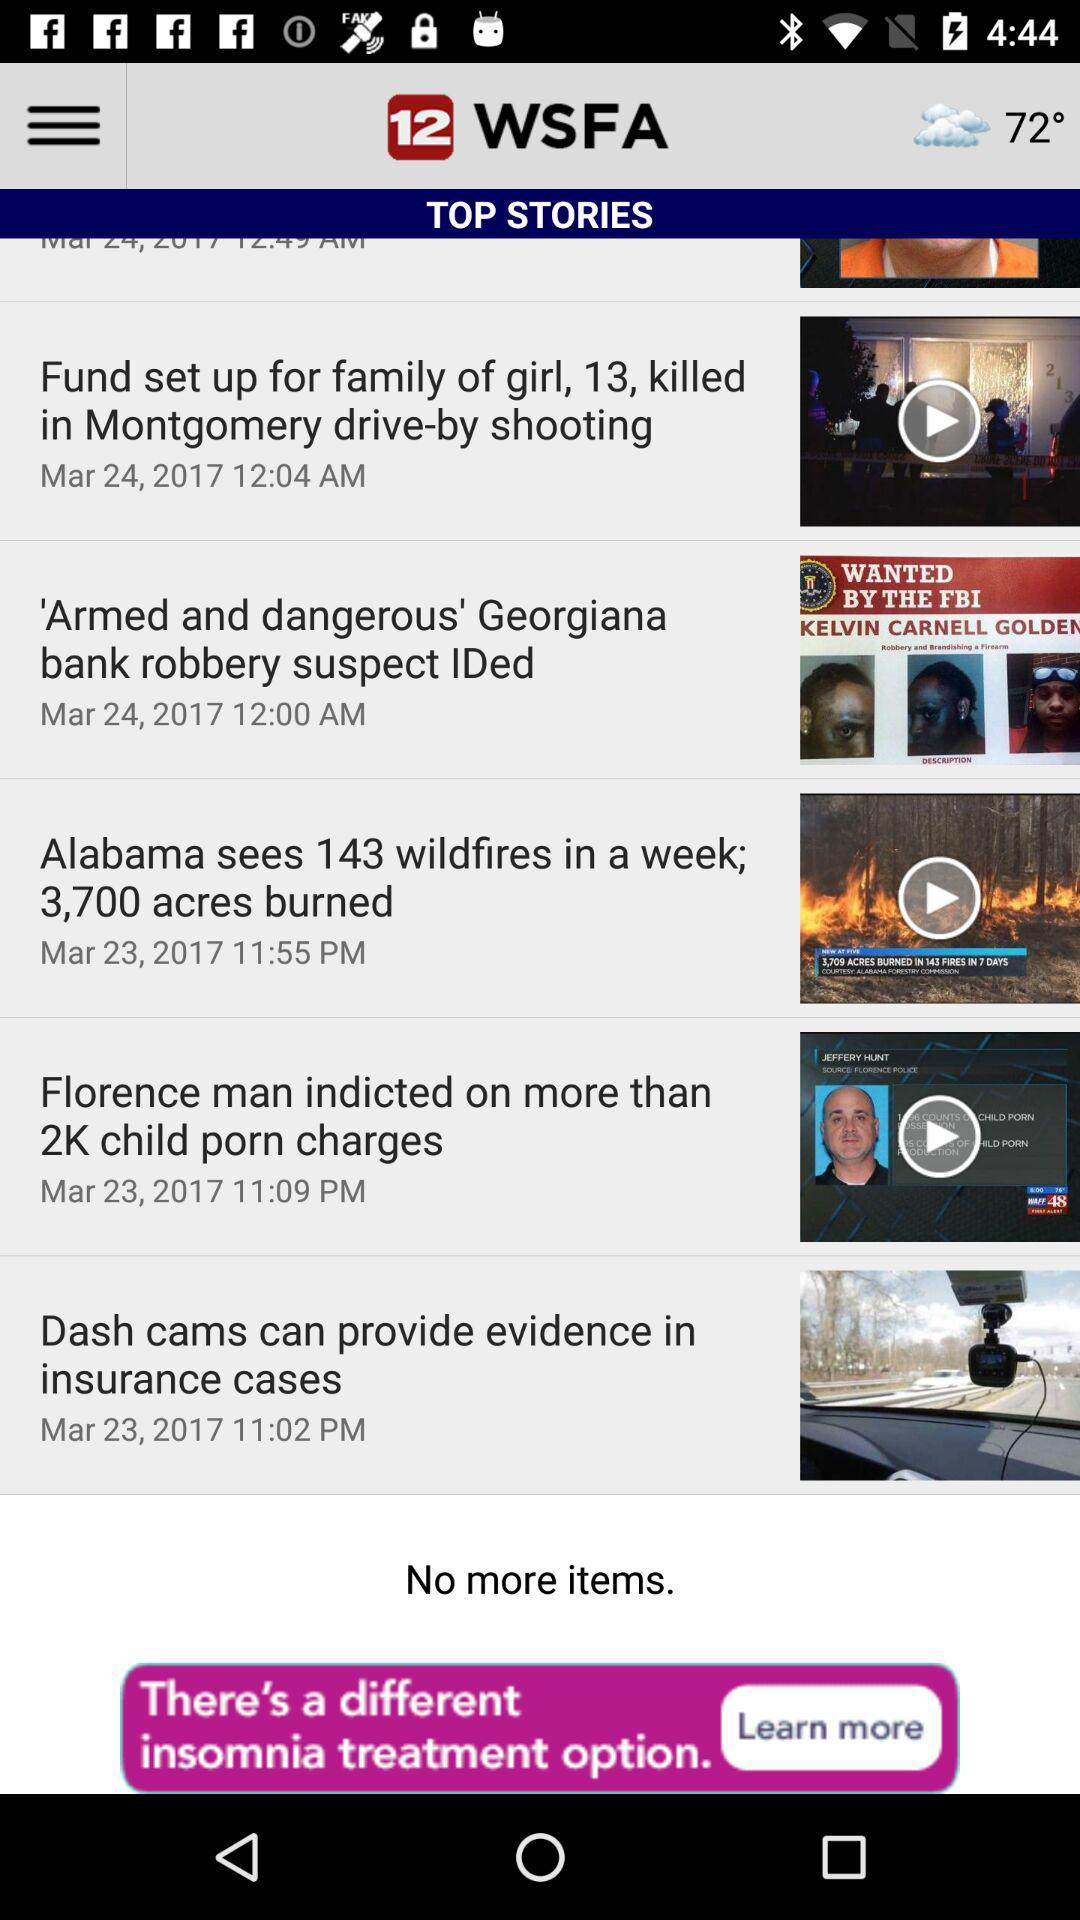At which time was the story "Alabama sees 143 wildfires in a week; 3,700 acres burned" posted? The story was posted at 11:55 PM. 